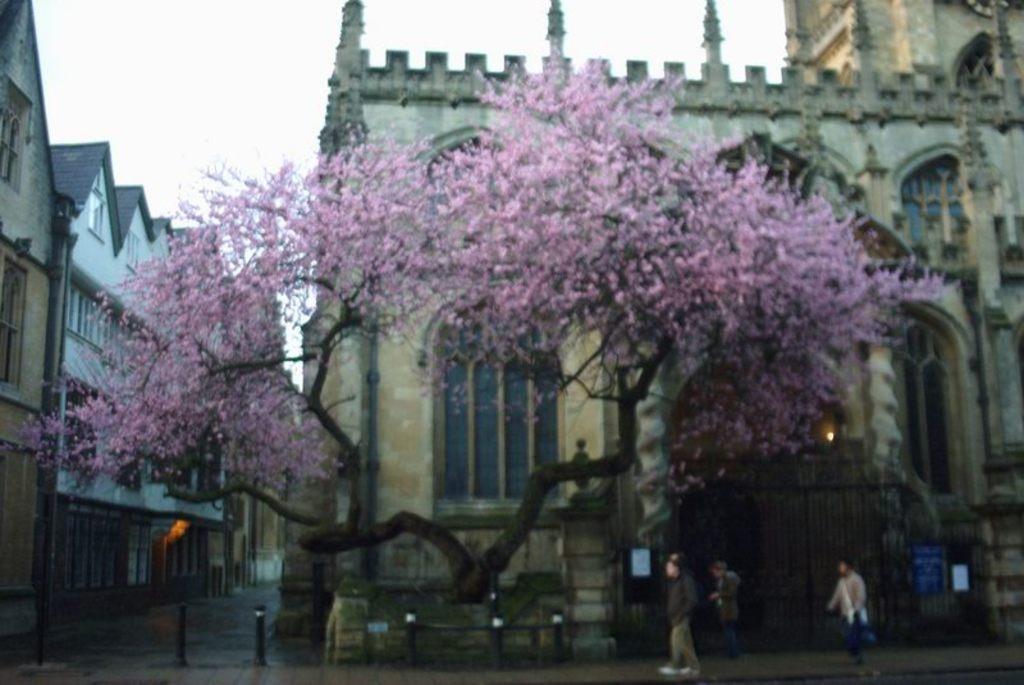Describe this image in one or two sentences. In this image, we can see tree, buildings, walls, windows, glass objects and light. At the bottom, we can see poles, boards, grille and few people on the walkway. Background we can see the sky. 